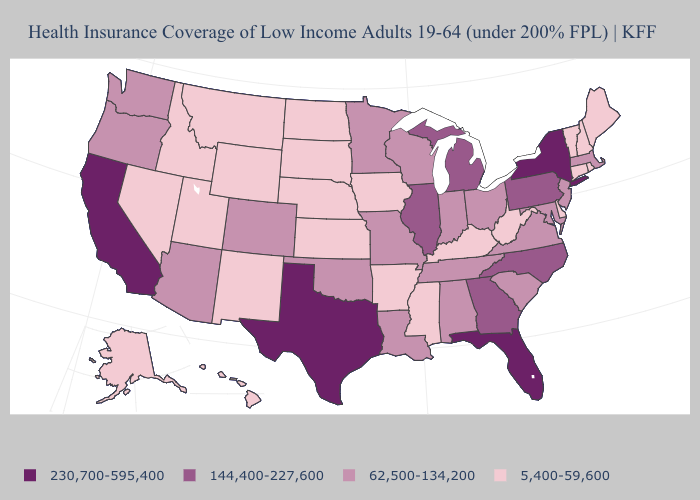Does Alaska have the lowest value in the USA?
Give a very brief answer. Yes. Among the states that border Florida , which have the highest value?
Short answer required. Georgia. Name the states that have a value in the range 62,500-134,200?
Keep it brief. Alabama, Arizona, Colorado, Indiana, Louisiana, Maryland, Massachusetts, Minnesota, Missouri, New Jersey, Ohio, Oklahoma, Oregon, South Carolina, Tennessee, Virginia, Washington, Wisconsin. What is the value of New Jersey?
Be succinct. 62,500-134,200. Name the states that have a value in the range 144,400-227,600?
Answer briefly. Georgia, Illinois, Michigan, North Carolina, Pennsylvania. Among the states that border Arkansas , does Tennessee have the highest value?
Concise answer only. No. Among the states that border Rhode Island , does Connecticut have the highest value?
Answer briefly. No. What is the highest value in the USA?
Short answer required. 230,700-595,400. Name the states that have a value in the range 230,700-595,400?
Keep it brief. California, Florida, New York, Texas. What is the highest value in the USA?
Short answer required. 230,700-595,400. Is the legend a continuous bar?
Give a very brief answer. No. Name the states that have a value in the range 230,700-595,400?
Concise answer only. California, Florida, New York, Texas. How many symbols are there in the legend?
Quick response, please. 4. Name the states that have a value in the range 62,500-134,200?
Write a very short answer. Alabama, Arizona, Colorado, Indiana, Louisiana, Maryland, Massachusetts, Minnesota, Missouri, New Jersey, Ohio, Oklahoma, Oregon, South Carolina, Tennessee, Virginia, Washington, Wisconsin. What is the lowest value in the USA?
Answer briefly. 5,400-59,600. 